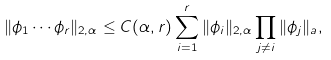Convert formula to latex. <formula><loc_0><loc_0><loc_500><loc_500>\| \phi _ { 1 } \cdots \phi _ { r } \| _ { 2 , \alpha } \leq C ( \alpha , r ) \sum _ { i = 1 } ^ { r } \| \phi _ { i } \| _ { 2 , \alpha } \prod _ { j \ne i } \| \phi _ { j } \| _ { a } ,</formula> 